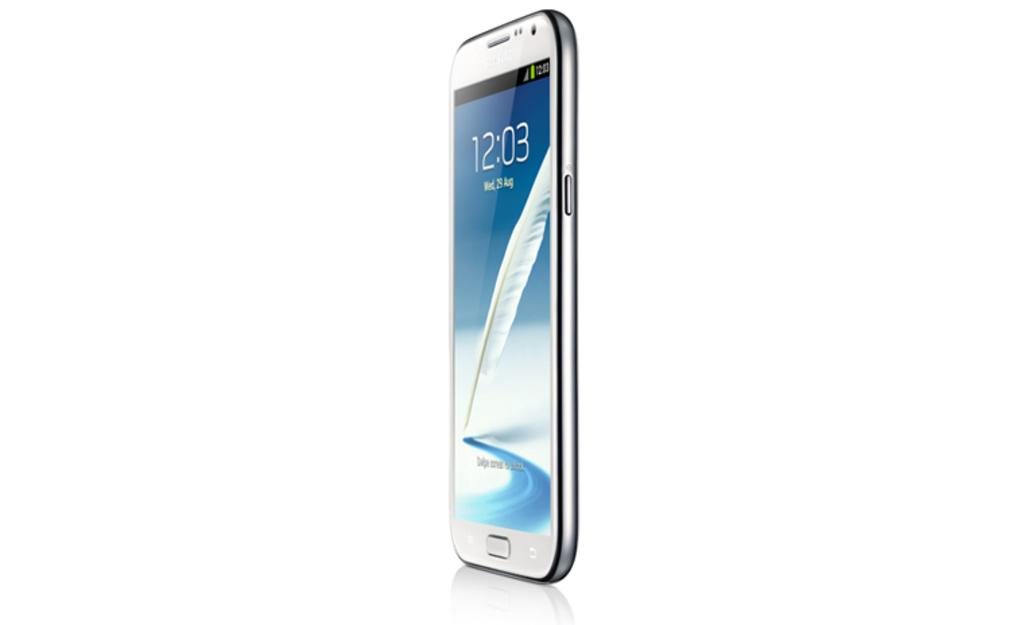<image>
Relay a brief, clear account of the picture shown. A cell phone is standing up on it's end with a time displayed on it as 12:03. 